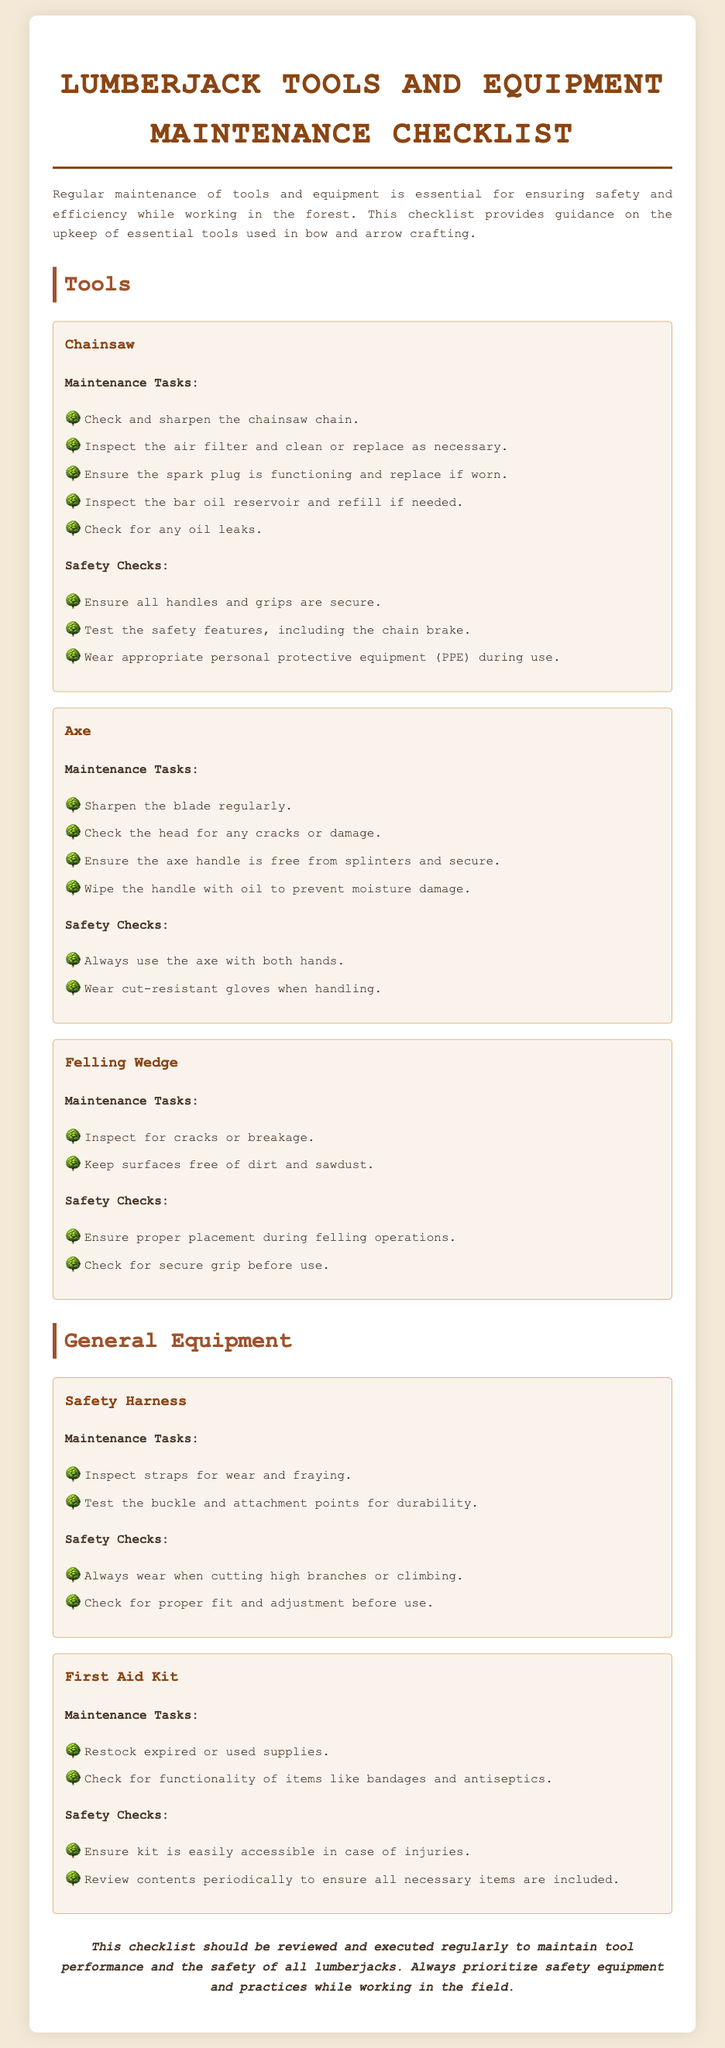What are the maintenance tasks for a chainsaw? The maintenance tasks for a chainsaw are listed under that section, including checking and sharpening the chainsaw chain and inspecting the air filter.
Answer: Check and sharpen the chainsaw chain, inspect the air filter, ensure the spark plug is functioning, inspect the bar oil reservoir, check for any oil leaks What should you inspect with the axe? This is part of the axe maintenance tasks, which require checking the axe head for any cracks or damage.
Answer: Check the head for any cracks or damage What should you do before using the safety harness? The document specifies that you should check for proper fit and adjustment before using the safety harness.
Answer: Check for proper fit and adjustment What items are included in the first aid kit maintenance tasks? The first aid kit maintenance tasks mention restocking expired or used supplies and checking the functionality of items.
Answer: Restock expired or used supplies, check for functionality How many maintenance tasks are listed for the felling wedge? The document contains two maintenance tasks for the felling wedge, which can be counted in the relevant section.
Answer: Two Why is wearing cut-resistant gloves advised? The document states that cut-resistant gloves should be worn when handling the axe for safety reasons.
Answer: For safety What safety check should be conducted for the chainsaw? One of the safety checks for the chainsaw is to test the safety features, including the chain brake.
Answer: Test the safety features, including the chain brake What should you regularly perform for the axe blade? The recommended action in the axe maintenance tasks section is to sharpen the blade regularly.
Answer: Sharpen the blade regularly 